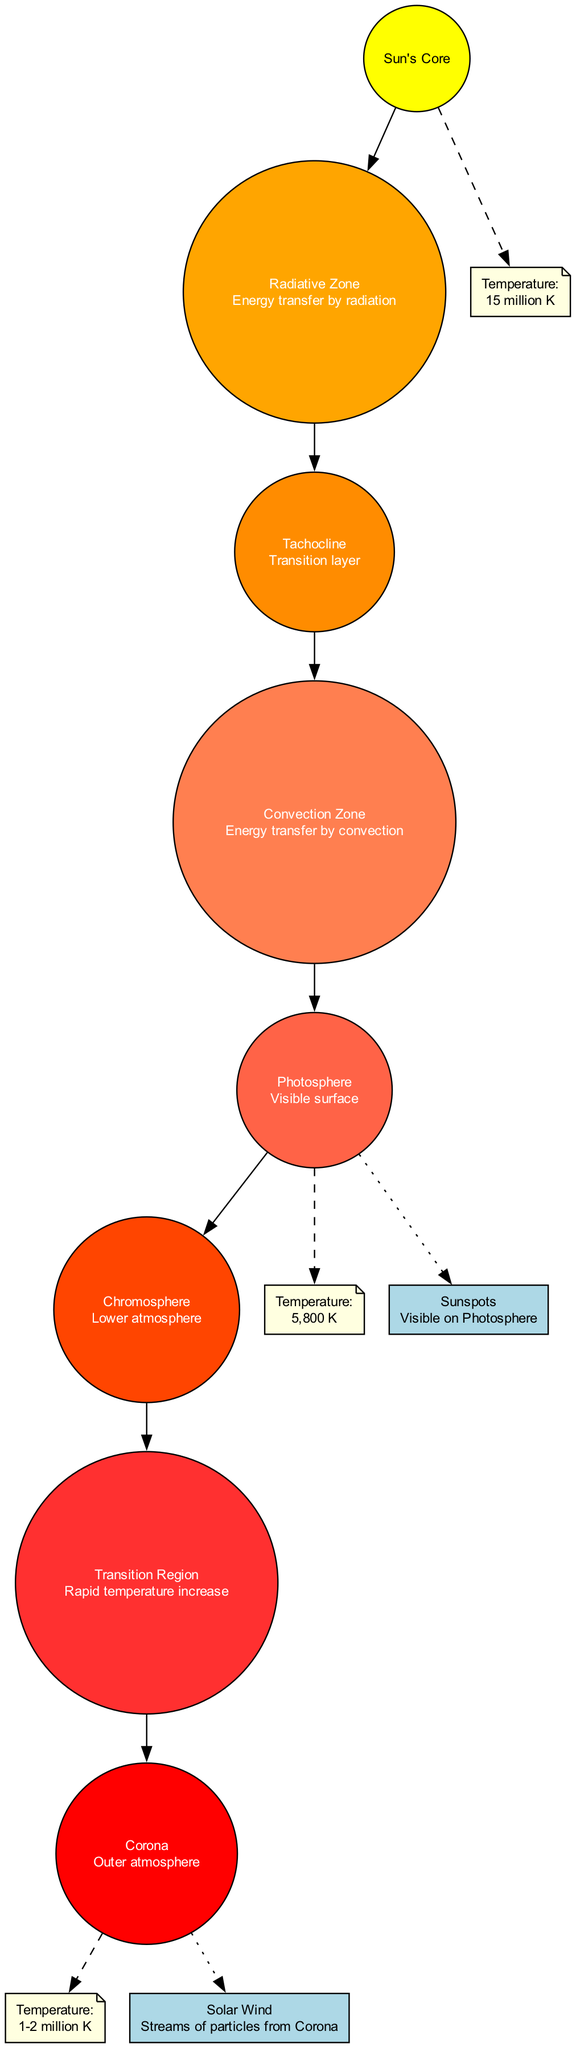What is the center object of the diagram? The center object is explicitly labeled at the center of the diagram, and it is the "Sun's Core".
Answer: Sun's Core How many layers are there in the Sun's atmosphere? The diagram presents a total of seven layers listed under "layers", counting from the core to the corona, which shows the number of layers.
Answer: 7 What is the temperature of the Sun's Core? The temperature information is provided through a node connected to the Sun's Core, indicating that the temperature is "15 million K".
Answer: 15 million K Which layer has energy transfer by convection? By examining the descriptions of each layer, the "Convection Zone" is noted for its method of energy transfer, which is by convection.
Answer: Convection Zone What is the temperature of the Photosphere? The diagram shows a node connected to the "Photosphere" layer that states its temperature is "5,800 K".
Answer: 5,800 K Where does solar wind originate according to the diagram? The diagram indicates that the "Solar Wind" streams are connected through a dotted edge to the "Corona" layer, which denotes the origin of solar wind.
Answer: Corona What is the relationship between the Tachocline and the Convection Zone? The diagram illustrates a direct connection (edge) between the "Tachocline" and the "Convection Zone", indicating that they are sequential layers adjacent to each other.
Answer: Direct connection What is the purpose of the Transition Region? The description in the diagram explains that the "Transition Region" is characterized by a rapid increase in temperature, indicating its role in the atmospheric structure.
Answer: Rapid temperature increase Which layer is visible on the Photosphere? The diagram includes a note connected to the "Photosphere" indicating the presence of "Sunspots", which are visible features within that layer.
Answer: Sunspots 